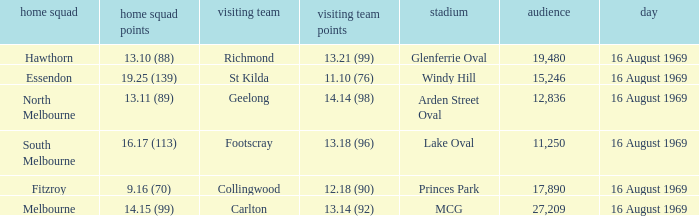When was the game played at Lake Oval? 16 August 1969. 